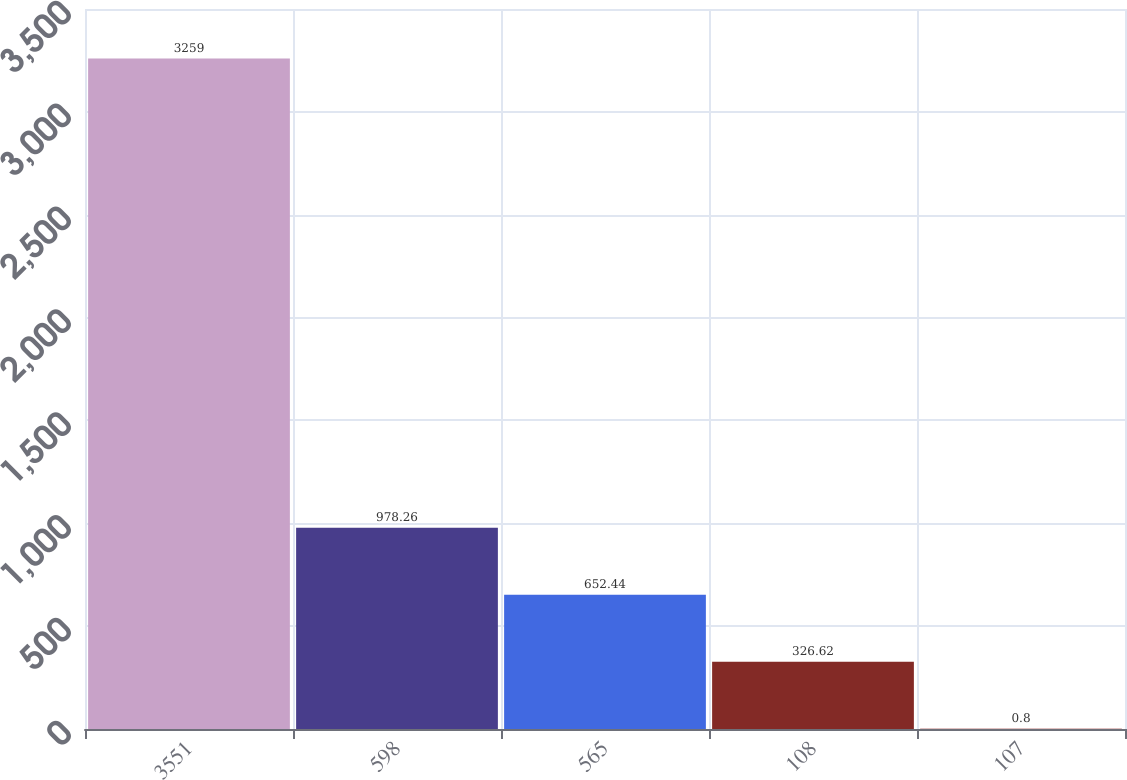<chart> <loc_0><loc_0><loc_500><loc_500><bar_chart><fcel>3551<fcel>598<fcel>565<fcel>108<fcel>107<nl><fcel>3259<fcel>978.26<fcel>652.44<fcel>326.62<fcel>0.8<nl></chart> 